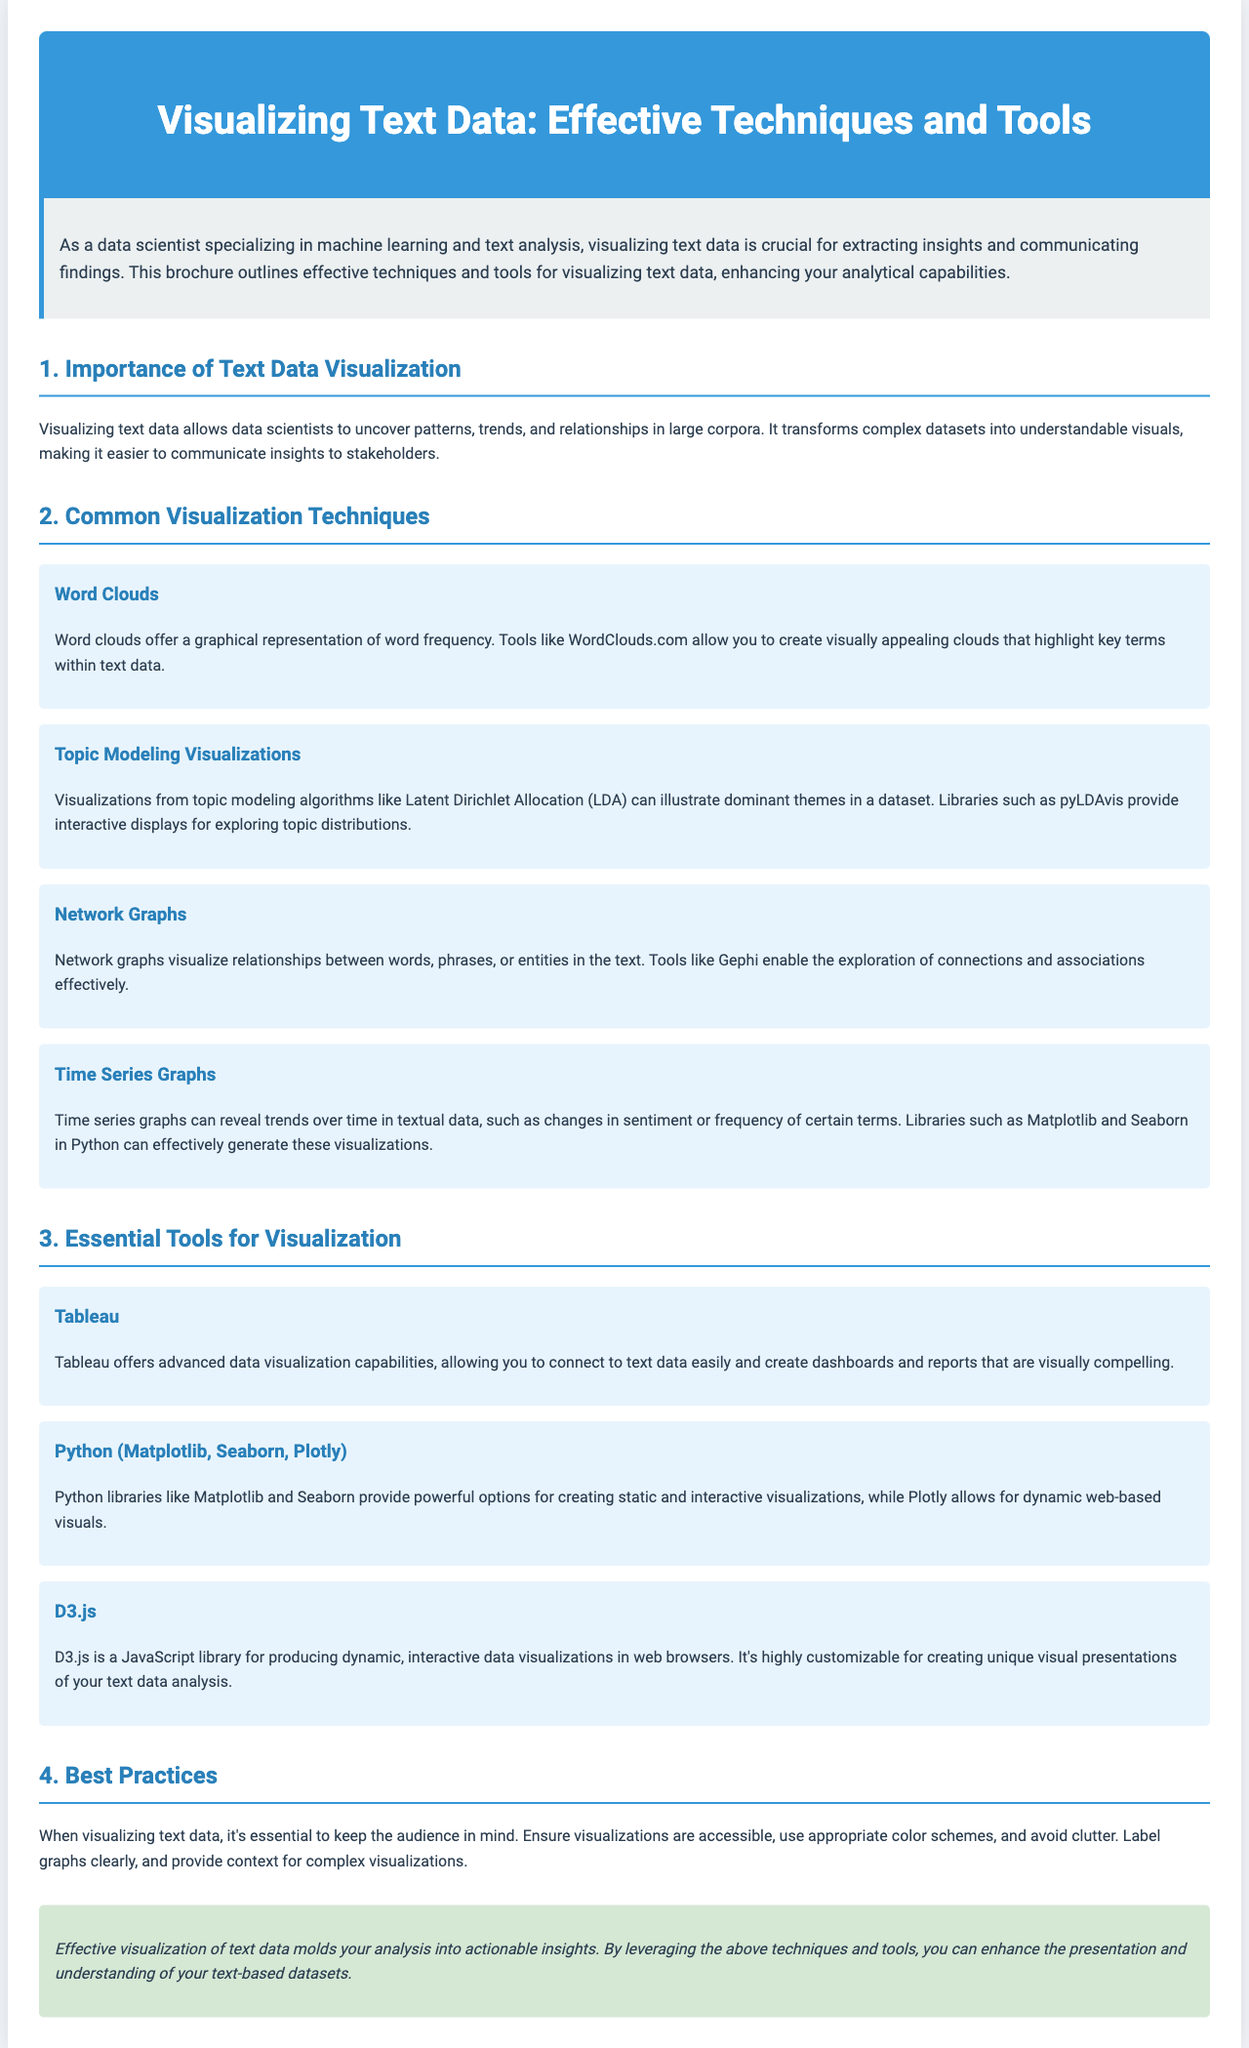What is the title of the brochure? The title of the brochure is mentioned in the header section.
Answer: Visualizing Text Data: Effective Techniques and Tools What is one common visualization technique mentioned? The document lists several common visualization techniques in a specified section.
Answer: Word Clouds Which tool provides advanced data visualization capabilities? This question relates to the section discussing essential tools for visualization.
Answer: Tableau What is a purpose of visualizing text data? The importance of text data visualization is outlined in the introduction section of the document.
Answer: Uncover patterns Which JavaScript library is mentioned for interactive data visualizations? This is found in the section discussing essential tools for visualization.
Answer: D3.js What should be avoided when visualizing text data according to best practices? The document discusses best practices for visualizing text data and mentions this explicitly.
Answer: Clutter How many visualization techniques are mentioned in the brochure? Count the techniques listed in the respective section of the document.
Answer: Four What do topic modeling visualizations help illustrate? This is specified in the description of topic modeling visualizations.
Answer: Dominant themes What is the styling theme of the brochure background? Refers to background color mentioned in the stylesheet of the document.
Answer: Light blue 